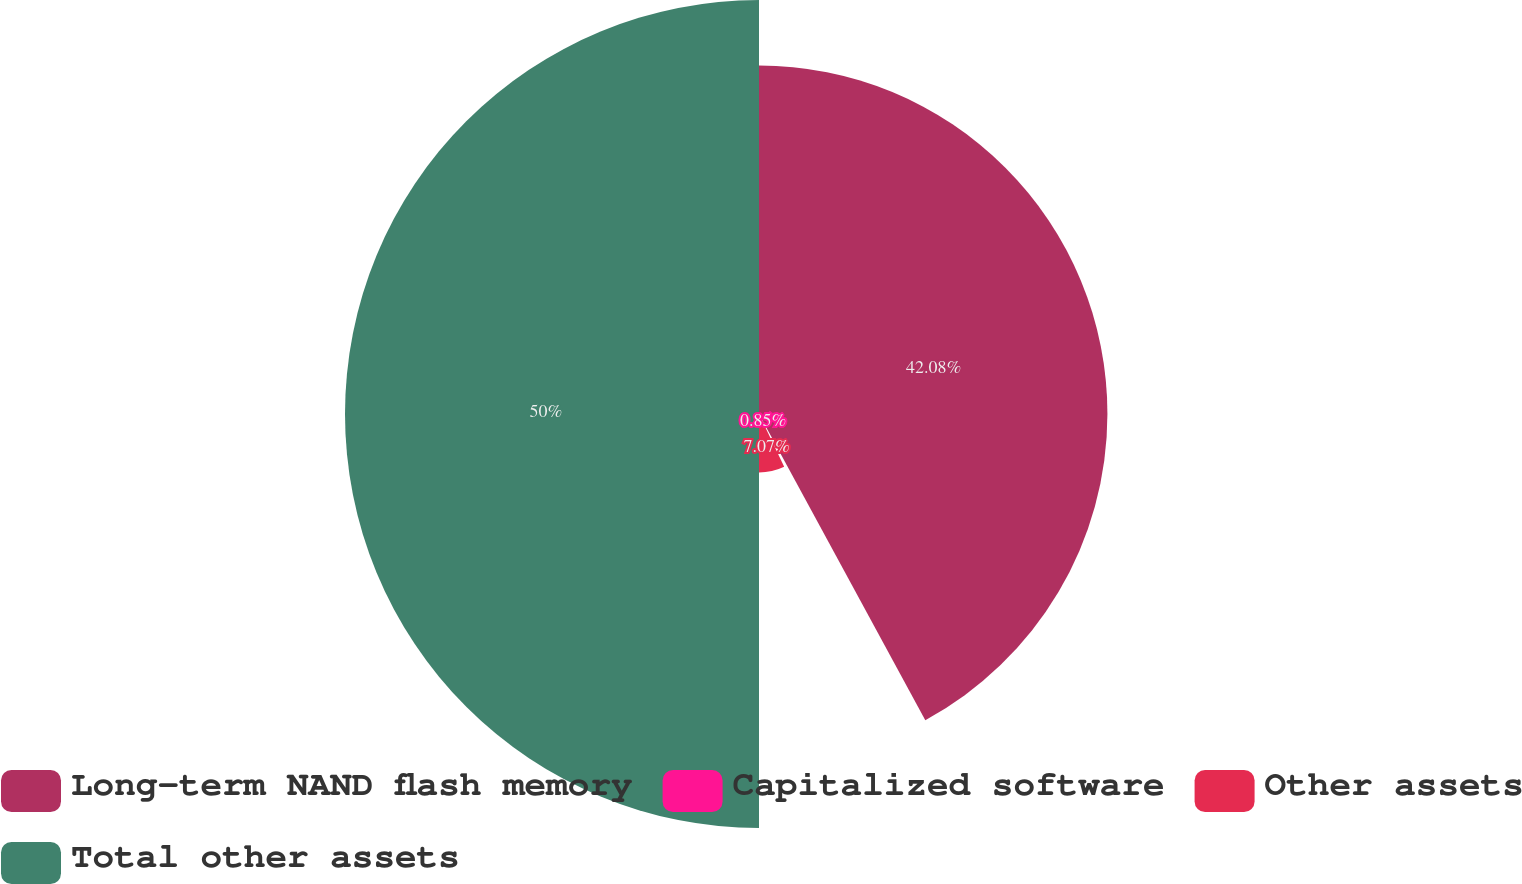<chart> <loc_0><loc_0><loc_500><loc_500><pie_chart><fcel>Long-term NAND flash memory<fcel>Capitalized software<fcel>Other assets<fcel>Total other assets<nl><fcel>42.08%<fcel>0.85%<fcel>7.07%<fcel>50.0%<nl></chart> 